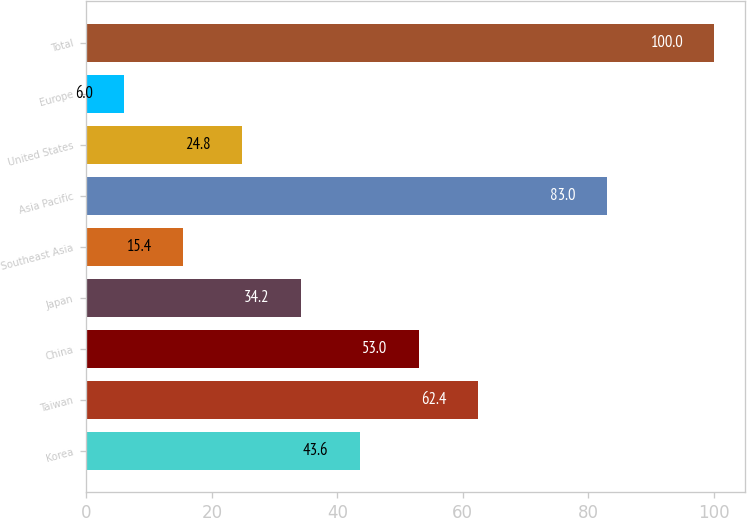Convert chart to OTSL. <chart><loc_0><loc_0><loc_500><loc_500><bar_chart><fcel>Korea<fcel>Taiwan<fcel>China<fcel>Japan<fcel>Southeast Asia<fcel>Asia Pacific<fcel>United States<fcel>Europe<fcel>Total<nl><fcel>43.6<fcel>62.4<fcel>53<fcel>34.2<fcel>15.4<fcel>83<fcel>24.8<fcel>6<fcel>100<nl></chart> 